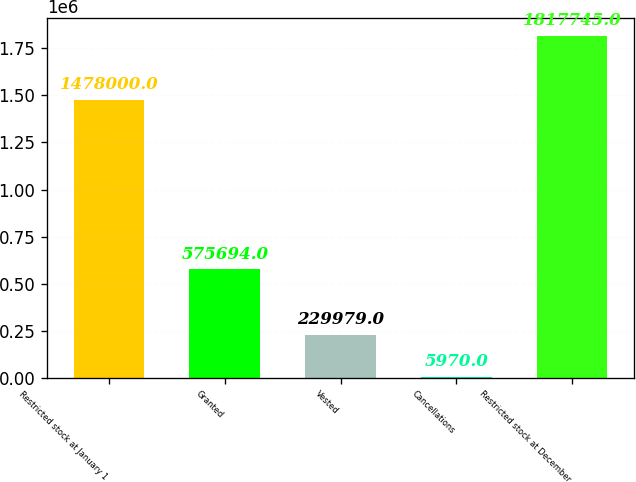<chart> <loc_0><loc_0><loc_500><loc_500><bar_chart><fcel>Restricted stock at January 1<fcel>Granted<fcel>Vested<fcel>Cancellations<fcel>Restricted stock at December<nl><fcel>1.478e+06<fcel>575694<fcel>229979<fcel>5970<fcel>1.81774e+06<nl></chart> 